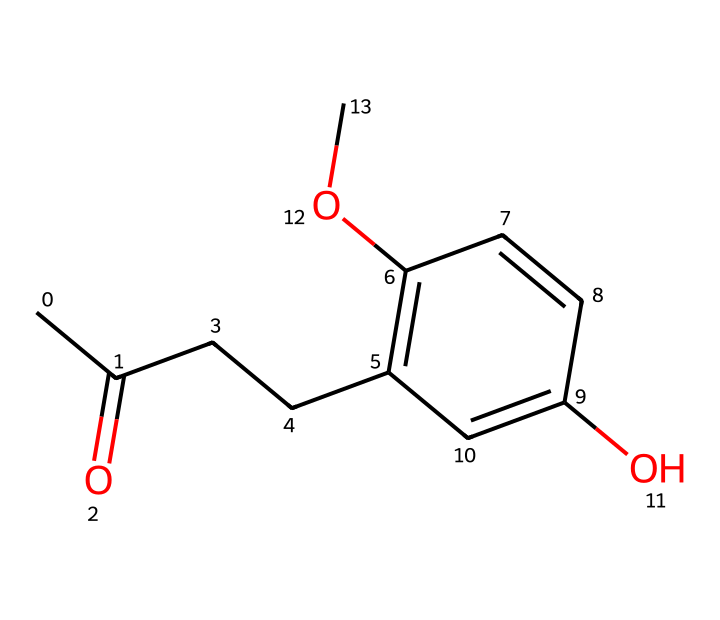What is the molecular formula of raspberry ketone? To determine the molecular formula, we analyze the SMILES representation to count the number of each type of atom present: Carbon (C), Hydrogen (H), and Oxygen (O). The structure indicates a total of 10 Carbon atoms, 12 Hydrogen atoms, and 2 Oxygen atoms, leading to the formula C10H12O2.
Answer: C10H12O2 How many carbon atoms are in raspberry ketone? By examining the SMILES notation, we find that the chain contains 10 carbon atoms which are denoted by the 'C' characters.
Answer: 10 What functional groups are present in raspberry ketone? Viewing the structure reveals a ketone group (C=O) present, and the presence of an ether group (-O-), confirming that these functional groups are part of the compound.
Answer: ketone, ether What is the degree of unsaturation in raspberry ketone? The degree of unsaturation can be calculated based on the molecular formula. From C10H12O2, we apply the formula: Degree of Unsaturation = (2C + 2 + N - H - X) / 2. Here it evaluates to (2(10) + 2 - 12)/2 = 5, indicating the presence of rings and/or double bonds.
Answer: 5 How many hydroxyl (-OH) groups are in raspberry ketone? The structure shows that there is one hydroxyl group (-OH) present in the chemical, as observed from the -O- connectivity around one carbon.
Answer: 1 What is the primary use of raspberry ketone? Raspberry ketone is mainly used as a dietary supplement for weight loss, as it is thought to increase fat metabolism and energy expenditure in the body.
Answer: weight loss 